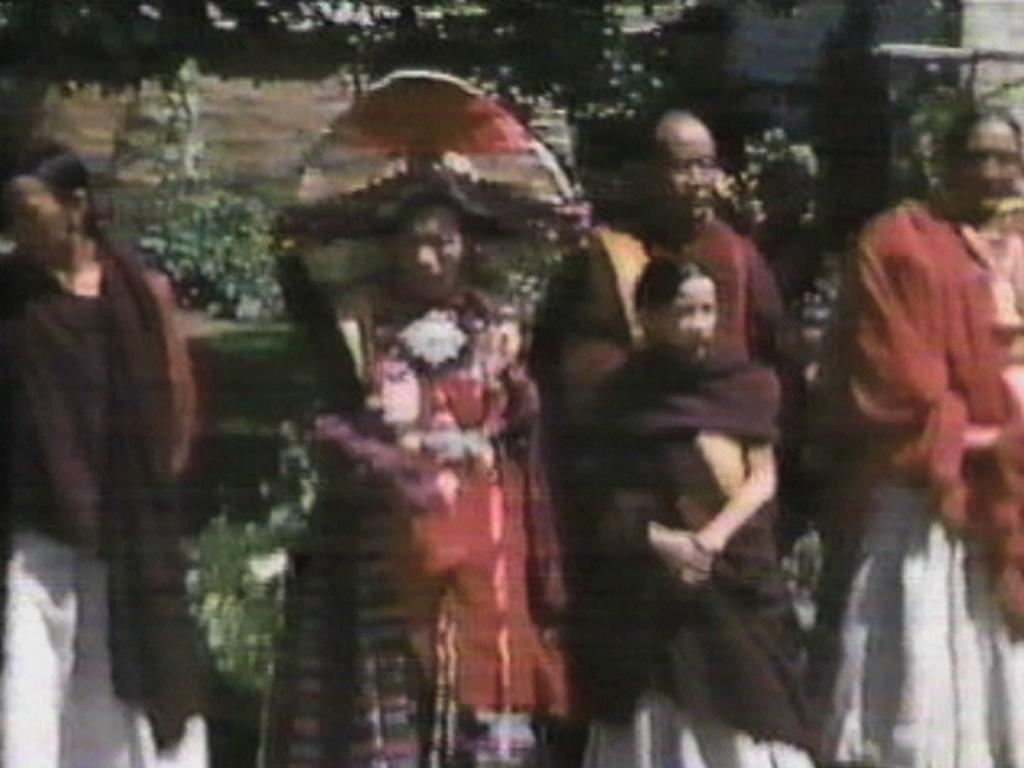Could you give a brief overview of what you see in this image? In this image I can see group of people standing. In front the person is wearing maroon and white color dress and the person at right is wearing red and white color dress. Background I can see trees in green color. 